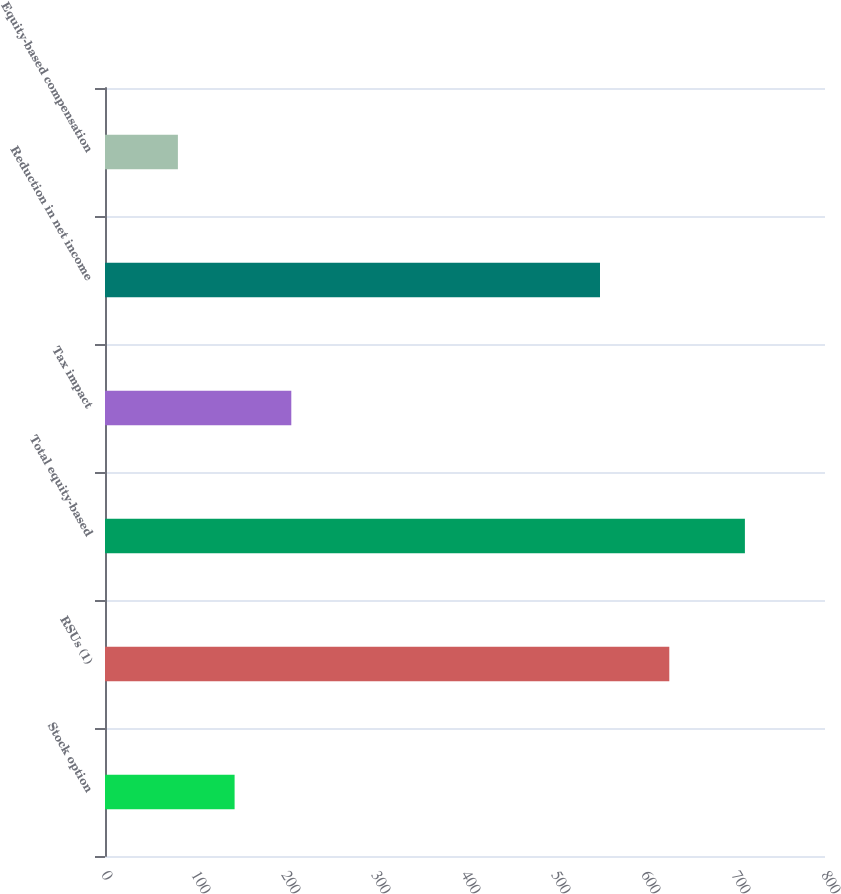<chart> <loc_0><loc_0><loc_500><loc_500><bar_chart><fcel>Stock option<fcel>RSUs (1)<fcel>Total equity-based<fcel>Tax impact<fcel>Reduction in net income<fcel>Equity-based compensation<nl><fcel>144<fcel>627<fcel>711<fcel>207<fcel>550<fcel>81<nl></chart> 